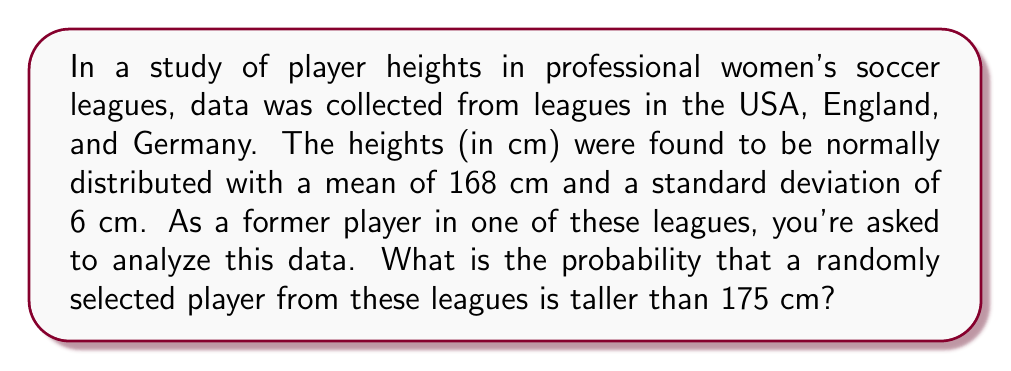Can you answer this question? To solve this problem, we need to use the properties of the normal distribution and the concept of z-scores.

1) We're given that the heights are normally distributed with:
   $\mu = 168$ cm (mean)
   $\sigma = 6$ cm (standard deviation)

2) We want to find $P(X > 175)$, where $X$ is the height of a randomly selected player.

3) To standardize this, we need to calculate the z-score for 175 cm:

   $$z = \frac{x - \mu}{\sigma} = \frac{175 - 168}{6} = \frac{7}{6} \approx 1.17$$

4) Now, we need to find $P(Z > 1.17)$, where $Z$ is the standard normal variable.

5) Using a standard normal table or calculator, we can find that:
   $P(Z < 1.17) \approx 0.8790$

6) Since we want the probability of being greater than 1.17, we subtract this from 1:

   $P(Z > 1.17) = 1 - P(Z < 1.17) = 1 - 0.8790 = 0.1210$

Therefore, the probability that a randomly selected player is taller than 175 cm is approximately 0.1210 or 12.10%.
Answer: 0.1210 or 12.10% 